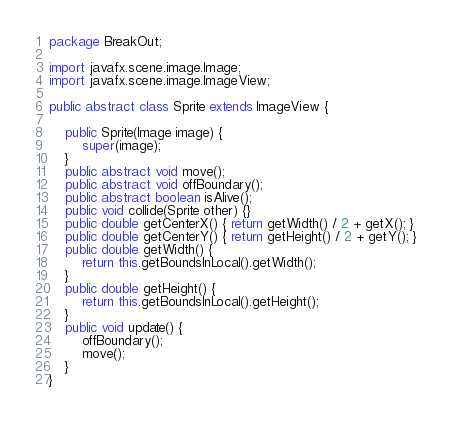<code> <loc_0><loc_0><loc_500><loc_500><_Java_>package BreakOut;

import javafx.scene.image.Image;
import javafx.scene.image.ImageView;

public abstract class Sprite extends ImageView {

    public Sprite(Image image) {
        super(image);
    }
    public abstract void move();
    public abstract void offBoundary();
    public abstract boolean isAlive();
    public void collide(Sprite other) {}
    public double getCenterX() { return getWidth() / 2 + getX(); }
    public double getCenterY() { return getHeight() / 2 + getY(); }
    public double getWidth() {
        return this.getBoundsInLocal().getWidth();
    }
    public double getHeight() {
        return this.getBoundsInLocal().getHeight();
    }
    public void update() {
        offBoundary();
        move();
    }
}</code> 